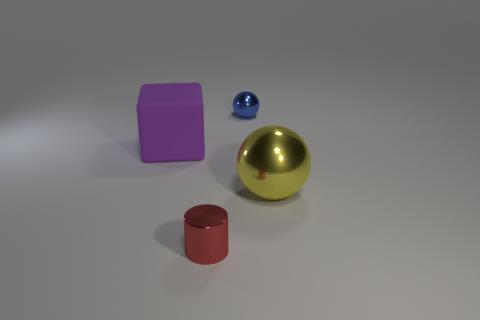What is the material of the ball in front of the metallic ball behind the purple object behind the cylinder?
Ensure brevity in your answer.  Metal. How many brown objects are small metallic cylinders or big matte objects?
Make the answer very short. 0. How big is the thing on the left side of the small thing left of the tiny object that is behind the tiny red object?
Your response must be concise. Large. The blue shiny object that is the same shape as the big yellow metallic thing is what size?
Give a very brief answer. Small. What number of large objects are yellow metal things or purple objects?
Provide a short and direct response. 2. Does the big thing in front of the purple rubber object have the same material as the tiny object that is in front of the large yellow ball?
Offer a very short reply. Yes. There is a large thing on the left side of the large shiny thing; what is its material?
Keep it short and to the point. Rubber. What number of rubber things are either tiny spheres or yellow spheres?
Your answer should be compact. 0. The thing in front of the large object on the right side of the cylinder is what color?
Ensure brevity in your answer.  Red. Are the tiny cylinder and the big thing that is left of the cylinder made of the same material?
Your response must be concise. No. 